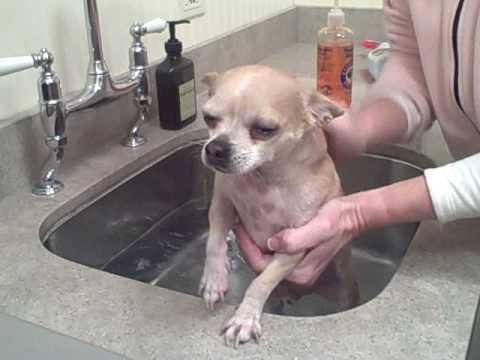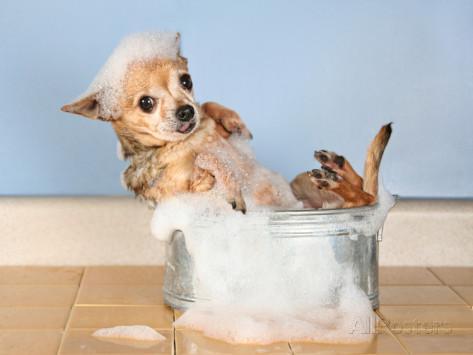The first image is the image on the left, the second image is the image on the right. Analyze the images presented: Is the assertion "Both images show a small dog in contact with water." valid? Answer yes or no. Yes. The first image is the image on the left, the second image is the image on the right. For the images displayed, is the sentence "One of the images shows a dog with bubbles on top of its head." factually correct? Answer yes or no. Yes. 